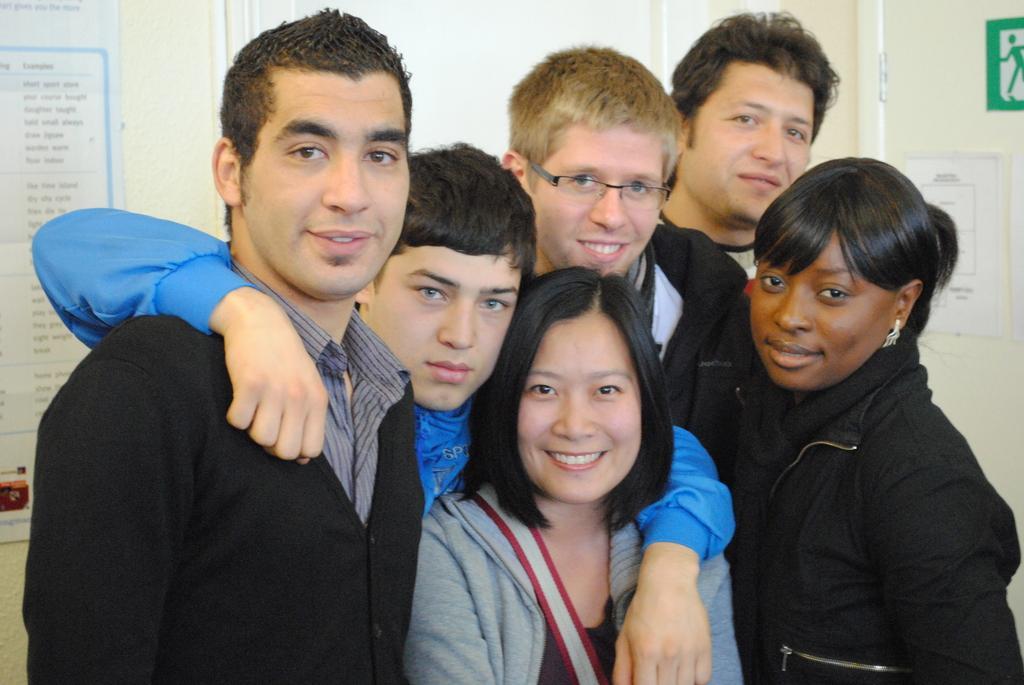Can you describe this image briefly? In this image we can see people standing. In the background there is a wall and we can see a board. On the right there is a door. 